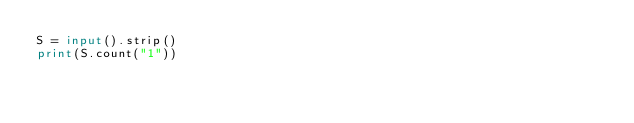<code> <loc_0><loc_0><loc_500><loc_500><_Python_>S = input().strip()
print(S.count("1"))</code> 